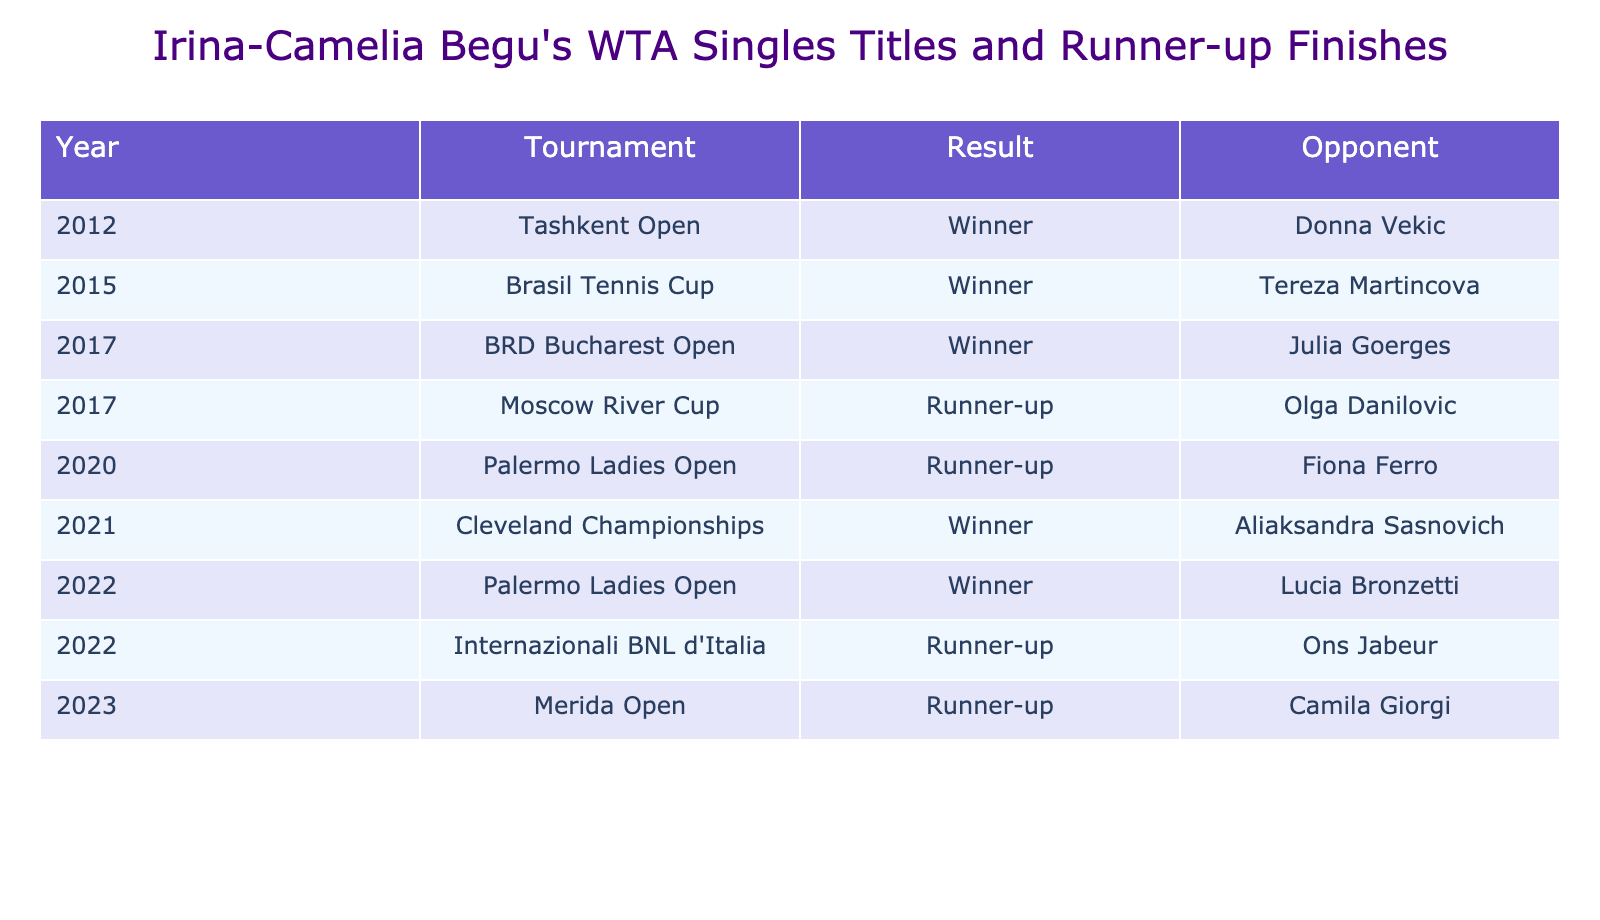What is the total number of WTA singles titles won by Irina-Camelia Begu? By counting the rows labeled as "Winner" in the "Result" column, we find that there are 5 titles in total: Tashkent Open (2012), Brasil Tennis Cup (2015), BRD Bucharest Open (2017), Cleveland Championships (2021), and Palermo Ladies Open (2022).
Answer: 5 How many times has Irina-Camelia Begu finished as a runner-up? By counting the rows labeled as "Runner-up" in the "Result" column, we see that she has finished as a runner-up 4 times: Moscow River Cup (2017), Palermo Ladies Open (2020), Internazionali BNL d'Italia (2022), and Merida Open (2023).
Answer: 4 In which year did Irina-Camelia Begu win her first WTA singles title? The first occurrence of "Winner" in the "Year" column is in 2012 for the Tashkent Open, indicating that this was her first title win.
Answer: 2012 Which opponent did Irina-Camelia Begu defeat to win her title at the BRD Bucharest Open? The table indicates that in 2017 at the BRD Bucharest Open, she defeated Julia Goerges, as listed under the "Opponent" column.
Answer: Julia Goerges Which runner-up finish was the most recent for Irina-Camelia Begu? Looking at the "Year" column, the most recent runner-up finish is listed in 2023 at the Merida Open, indicating this as her latest result.
Answer: Merida Open (2023) How many tournaments did Irina-Camelia Begu participate in as a runner-up before 2021? By examining the "Result" column, we see that she was a runner-up in two tournaments before 2021: Moscow River Cup (2017) and Palermo Ladies Open (2020).
Answer: 2 Was there a year when Irina-Camelia Begu both won a title and finished as a runner-up? Yes, if we check the data, in 2017 she won the BRD Bucharest Open and also finished as a runner-up at the Moscow River Cup within the same year.
Answer: Yes Which tournament had Irina-Camelia Begu finishing as a runner-up against a French opponent? The table indicates that she was the runner-up against Fiona Ferro at the Palermo Ladies Open in 2020, who is of French nationality.
Answer: Palermo Ladies Open (2020) Calculate the percentage of her matches that resulted in titles from her total participation as listed in the table. She has 5 victories (titles) and 4 runner-up finishes, totaling 9 appearances. To find the percentage: (5 titles/9 total appearances) * 100 = 55.56%.
Answer: 55.56% What is the most common outcome for Irina-Camelia Begu in the tournaments listed? By comparing the counts, we see she won 5 titles and was the runner-up 4 times; therefore, winning is the most common outcome since it has a higher count.
Answer: Winning How many of her runner-up finishes occurred on clay courts? The tournaments listed are not explicitly noted for their surfaces, but we can reasonably assume that the Internazionali BNL d'Italia is played on clay. Hence, among her 4 runner-up finishes, only this one can be confidently categorized as a clay court finish.
Answer: 1 